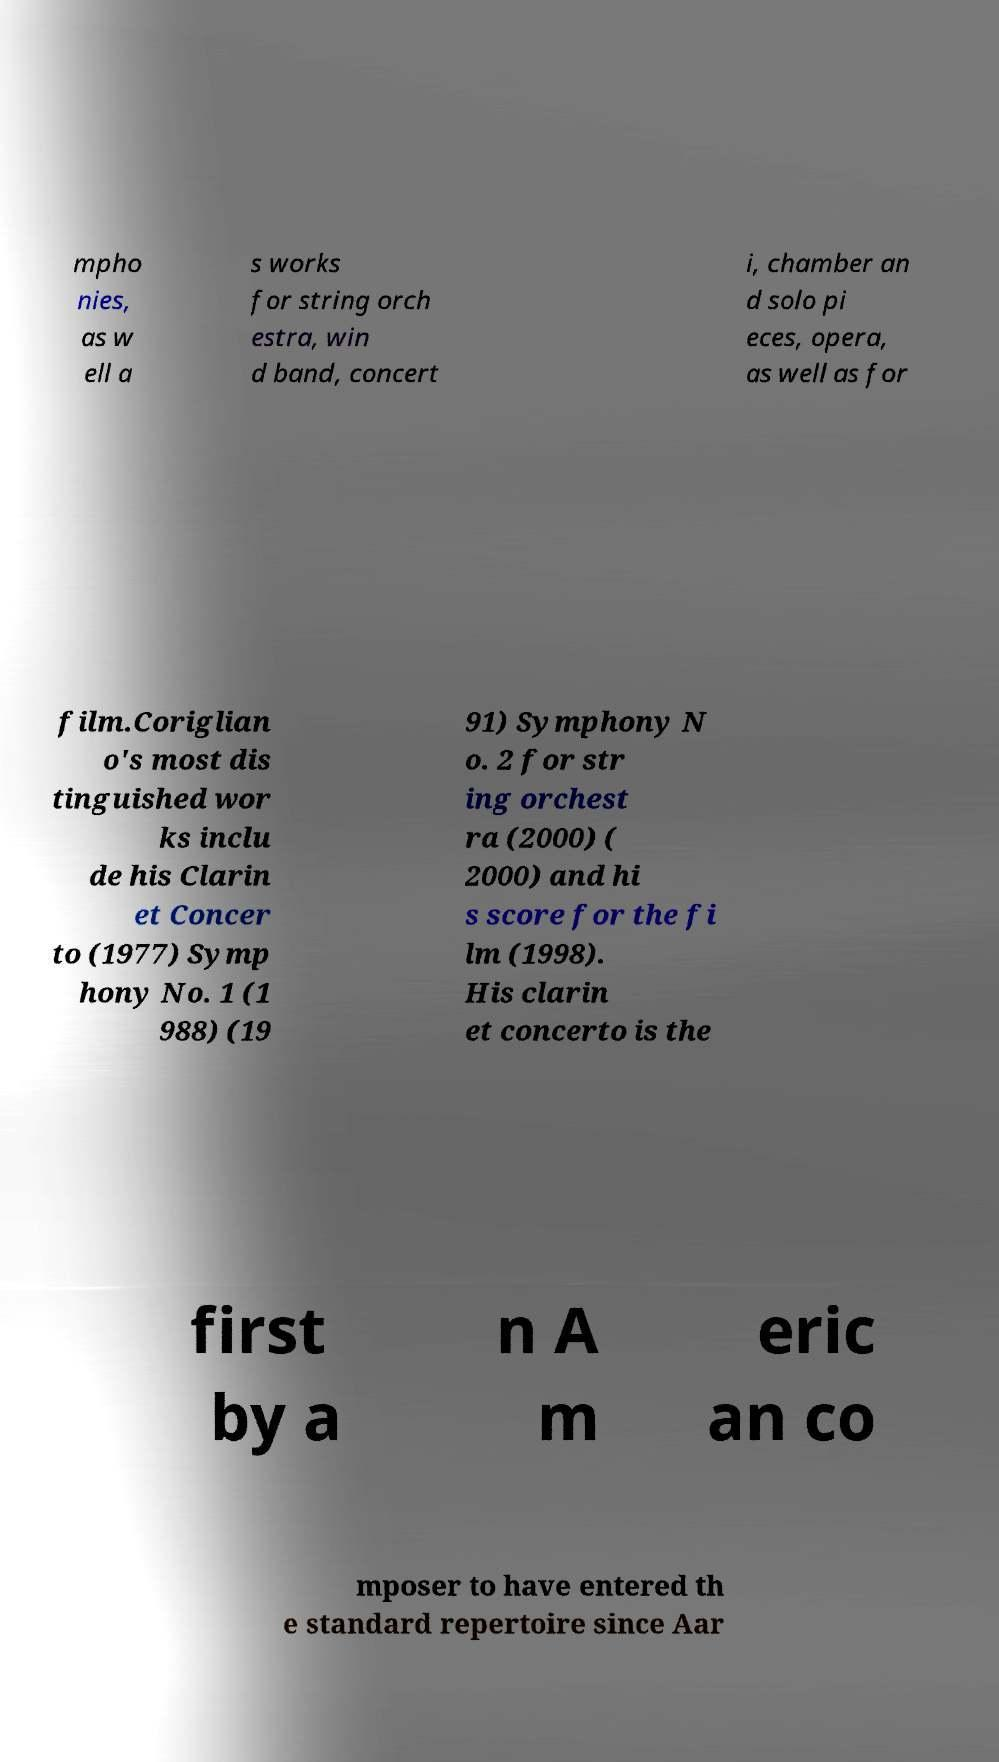Please read and relay the text visible in this image. What does it say? mpho nies, as w ell a s works for string orch estra, win d band, concert i, chamber an d solo pi eces, opera, as well as for film.Coriglian o's most dis tinguished wor ks inclu de his Clarin et Concer to (1977) Symp hony No. 1 (1 988) (19 91) Symphony N o. 2 for str ing orchest ra (2000) ( 2000) and hi s score for the fi lm (1998). His clarin et concerto is the first by a n A m eric an co mposer to have entered th e standard repertoire since Aar 